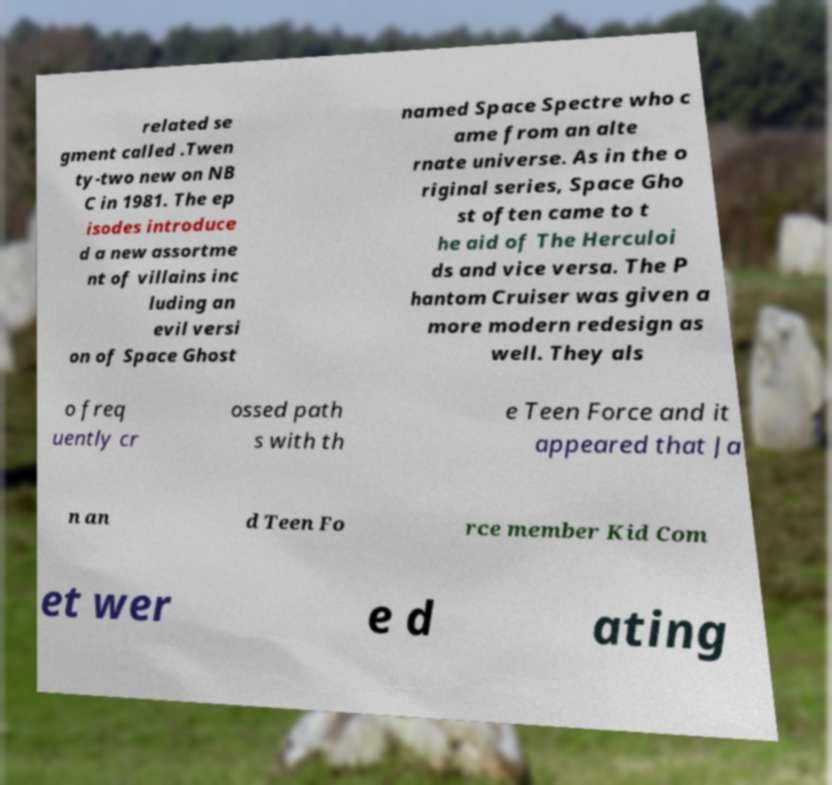What messages or text are displayed in this image? I need them in a readable, typed format. related se gment called .Twen ty-two new on NB C in 1981. The ep isodes introduce d a new assortme nt of villains inc luding an evil versi on of Space Ghost named Space Spectre who c ame from an alte rnate universe. As in the o riginal series, Space Gho st often came to t he aid of The Herculoi ds and vice versa. The P hantom Cruiser was given a more modern redesign as well. They als o freq uently cr ossed path s with th e Teen Force and it appeared that Ja n an d Teen Fo rce member Kid Com et wer e d ating 